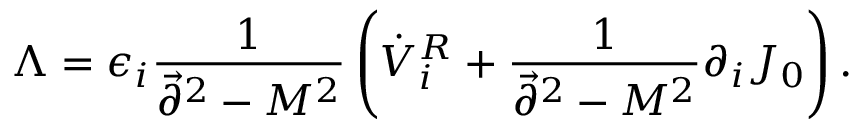<formula> <loc_0><loc_0><loc_500><loc_500>\Lambda = \epsilon _ { i } { \frac { 1 } { \vec { \partial } ^ { 2 } - M ^ { 2 } } } \left ( \dot { V } _ { i } ^ { R } + { \frac { 1 } { \vec { \partial } ^ { 2 } - M ^ { 2 } } } \partial _ { i } J _ { 0 } \right ) .</formula> 